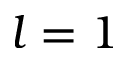Convert formula to latex. <formula><loc_0><loc_0><loc_500><loc_500>l = 1</formula> 